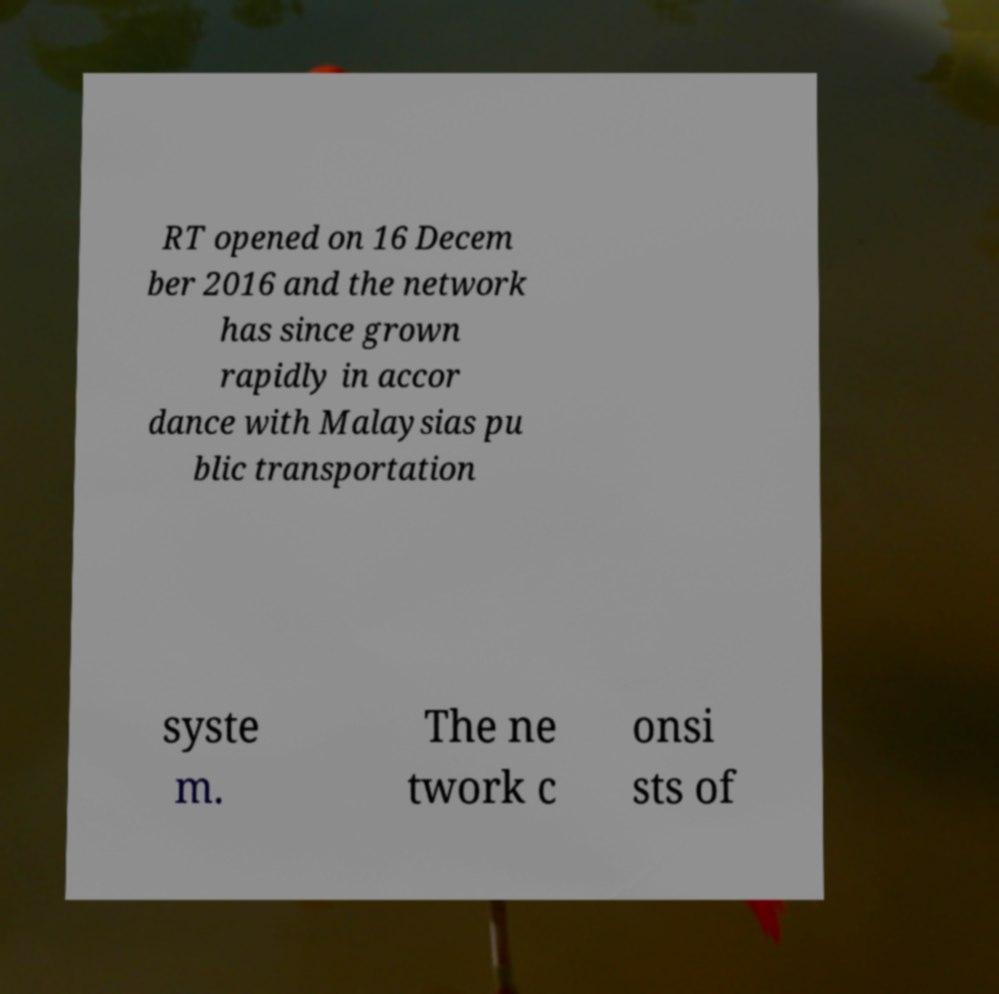Please read and relay the text visible in this image. What does it say? RT opened on 16 Decem ber 2016 and the network has since grown rapidly in accor dance with Malaysias pu blic transportation syste m. The ne twork c onsi sts of 